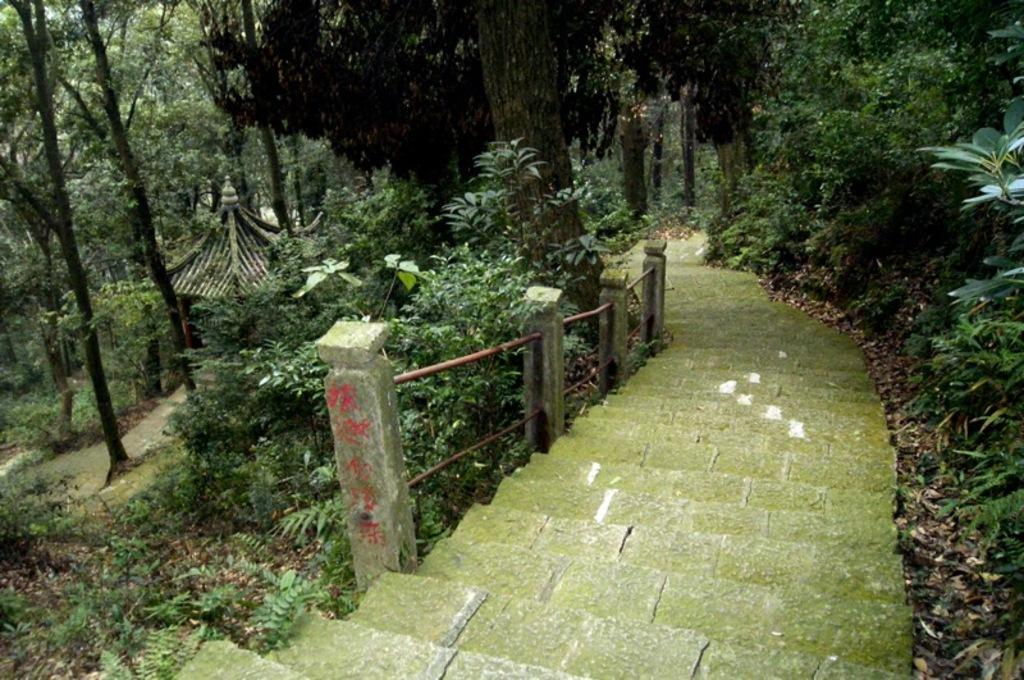Describe this image in one or two sentences. In the image there are steps and around those steps there are many trees. 